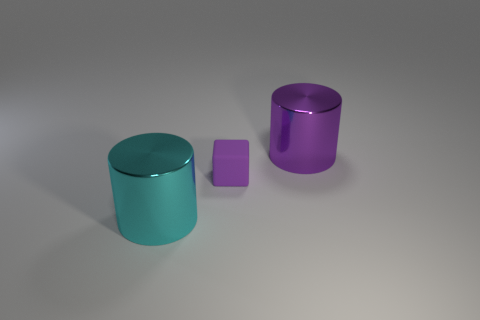Add 3 small yellow shiny cylinders. How many objects exist? 6 Add 2 small purple matte cubes. How many small purple matte cubes are left? 3 Add 1 tiny matte things. How many tiny matte things exist? 2 Subtract all purple cylinders. How many cylinders are left? 1 Subtract 0 red balls. How many objects are left? 3 Subtract all blocks. How many objects are left? 2 Subtract all gray cylinders. Subtract all brown spheres. How many cylinders are left? 2 Subtract all brown blocks. How many purple cylinders are left? 1 Subtract all tiny gray balls. Subtract all big metallic cylinders. How many objects are left? 1 